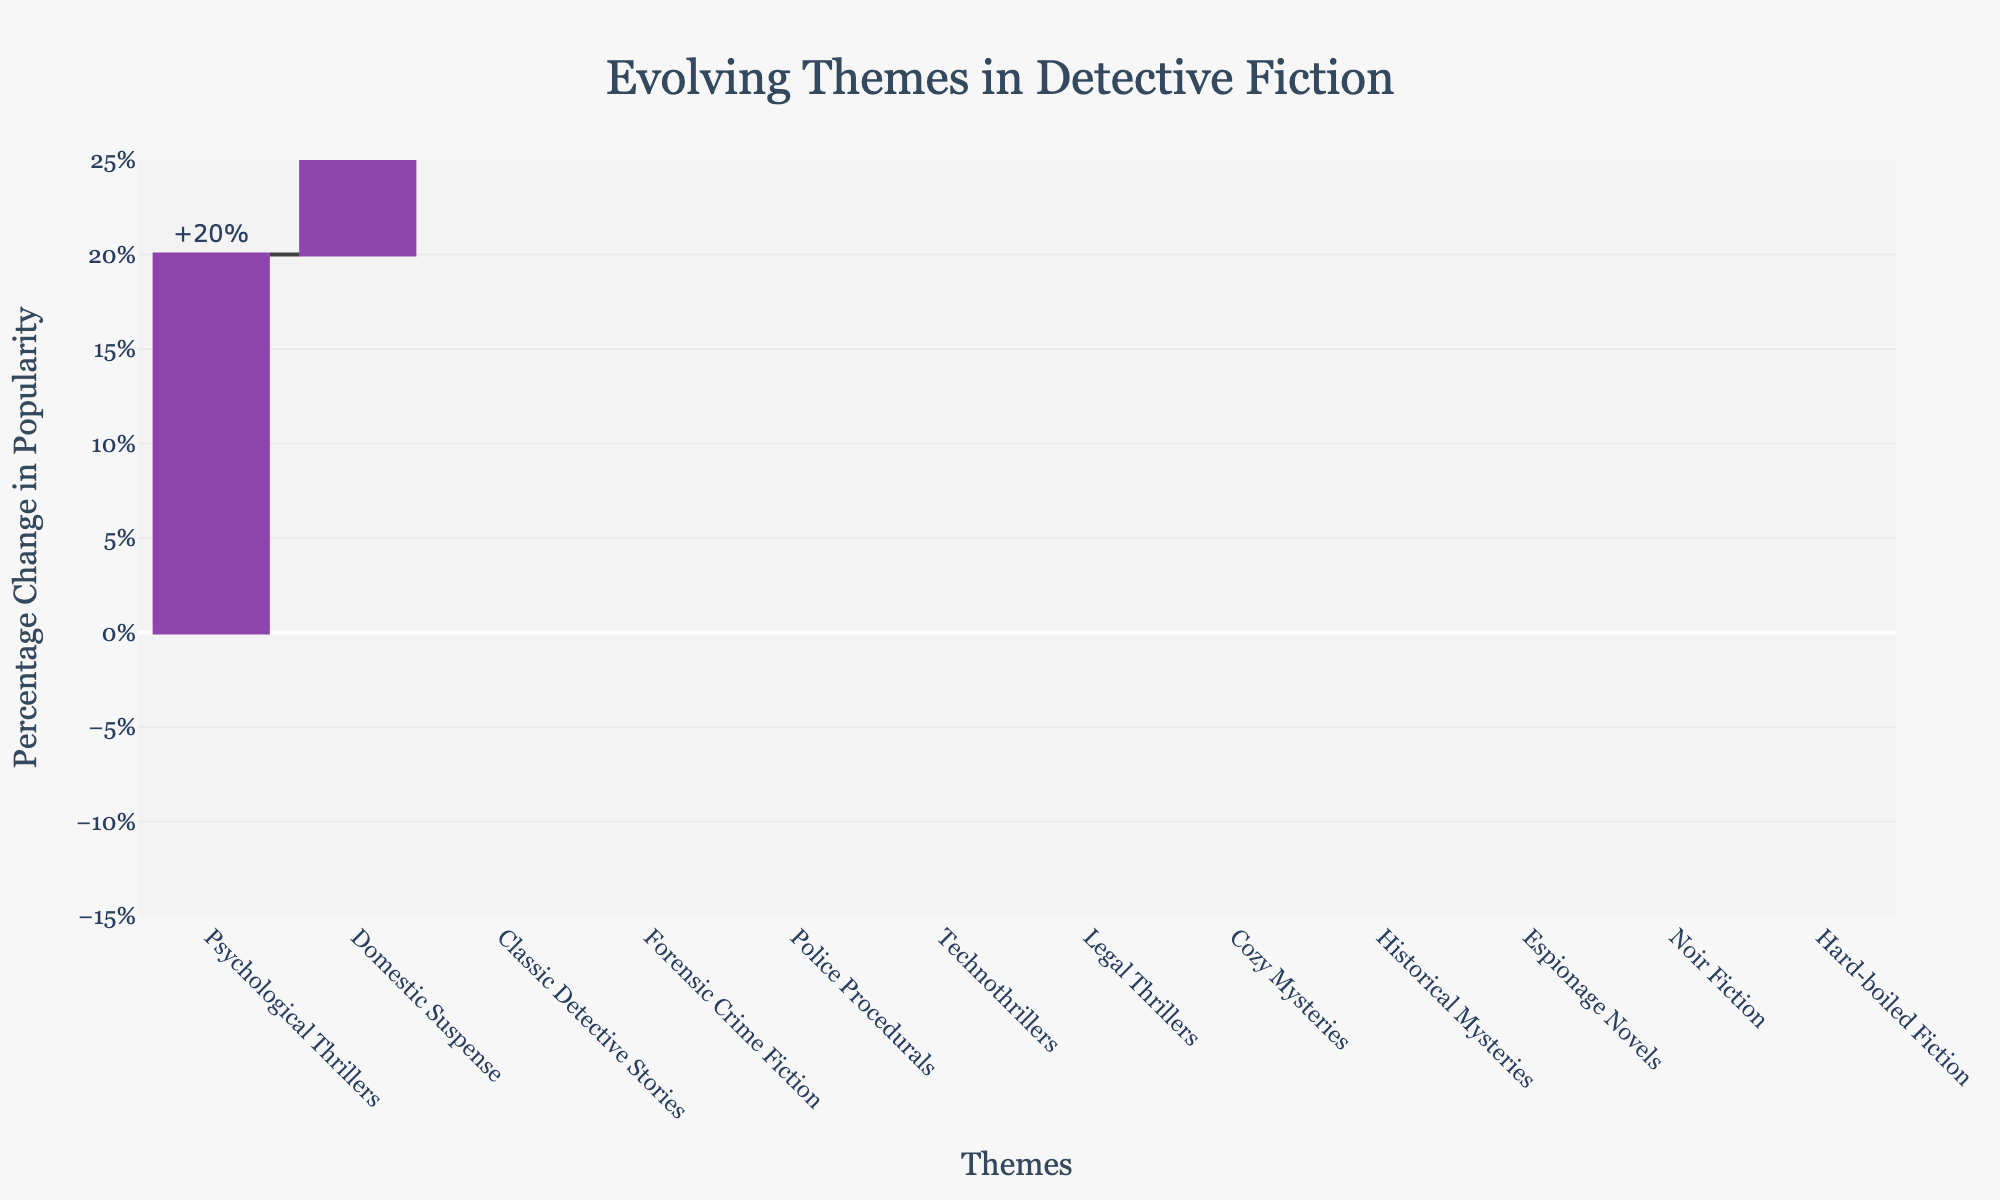Which theme shows the highest percentage increase in popularity? The theme with the highest bar extending upwards represents the highest percentage increase in popularity, which is Psychological Thrillers with +20%.
Answer: Psychological Thrillers Which theme has the largest decrease in popularity? The theme with the largest downward bar has the largest decrease. It is Hard-boiled Fiction with -8%.
Answer: Hard-boiled Fiction How much did the popularity of Classic Detective Stories change? The bar for Classic Detective Stories shows a +15% change, as indicated by the label on the bar.
Answer: +15% What is the percentage change in popularity for Legal Thrillers? The bar for Legal Thrillers shows a +7% change in popularity, as indicated by the label.
Answer: +7% Compare the popularity change between Technothrillers and Noir Fiction. Which one increased and by how much compared to the decrease of the other? Technothrillers increased by +8% while Noir Fiction decreased by -6%, so the difference is 8% - (-6%) = 14%.
Answer: Technothrillers increased by +8%, Noir Fiction decreased by -6% What is the sum of the percentage changes for all themes with increasing popularity? Sum the positive changes: 15 + 10 + 5 + 20 + 12 + 18 + 8 + 7 = 95%.
Answer: 95% Which themes have a positive change in popularity and by how much? The themes with bars extending upwards represent positive changes: Classic Detective Stories (+15%), Police Procedurals (+10%), Cozy Mysteries (+5%), Psychological Thrillers (+20%), Forensic Crime Fiction (+12%), Domestic Suspense (+18%), Technothrillers (+8%), Legal Thrillers (+7%).
Answer: 8 themes with varying percentages What is the range of percentage changes displayed in the chart? The range is from the lowest percentage change to the highest. The lowest is -8% for Hard-boiled Fiction, and the highest is +20% for Psychological Thrillers, so the range is -8% to +20%.
Answer: -8% to +20% Identify the themes that have a negative change in popularity. The bars extending downwards indicate negative changes: Hard-boiled Fiction (-8%), Historical Mysteries (-3%), Noir Fiction (-6%), Espionage Novels (-4%).
Answer: Four themes with varying percentages What is the average percentage change across all themes in the chart? Calculate the average by summing all changes and dividing by the number of themes. Sum of changes: 15 - 8 + 10 + 5 + 20 + 12 - 3 - 6 + 18 + 8 - 4 + 7 = 74. There are 12 themes, so the average is 74 / 12 ≈ 6.17%.
Answer: ≈ 6.17% 